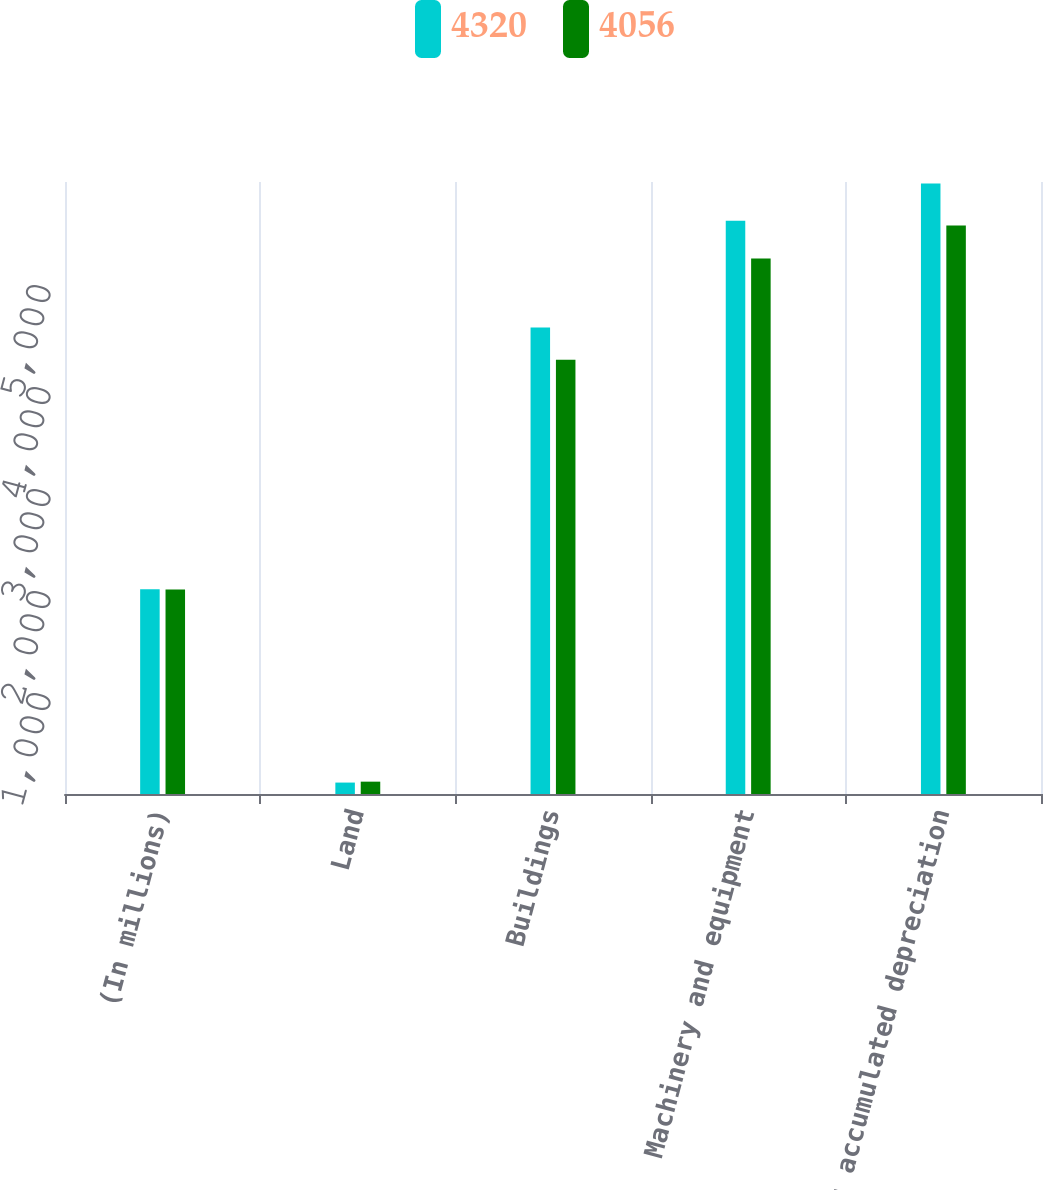Convert chart to OTSL. <chart><loc_0><loc_0><loc_500><loc_500><stacked_bar_chart><ecel><fcel>(In millions)<fcel>Land<fcel>Buildings<fcel>Machinery and equipment<fcel>Less accumulated depreciation<nl><fcel>4320<fcel>2007<fcel>112<fcel>4574<fcel>5619<fcel>5985<nl><fcel>4056<fcel>2006<fcel>121<fcel>4258<fcel>5250<fcel>5573<nl></chart> 